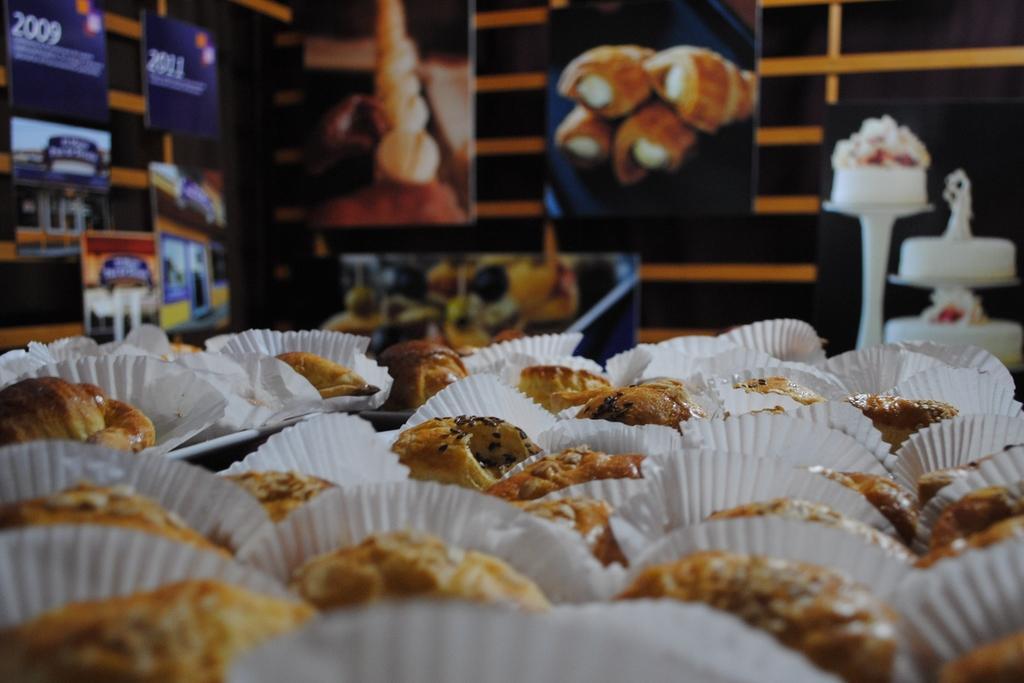In one or two sentences, can you explain what this image depicts? In this image there are some cupcakes in the bottom of this image. There are some photo frames of a food items and some other posters are on the wall. 